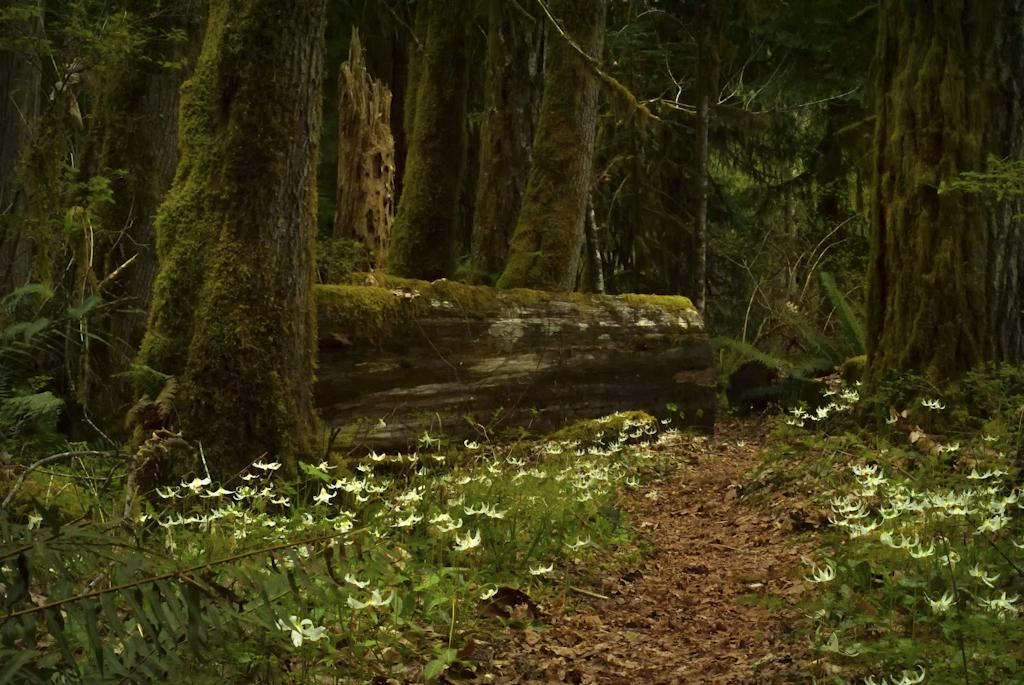What type of vegetation can be seen in the image? There are plants, flowers, and trees in the image. Can you describe the trees in the image? The trees in the image have tree trunks. How many pockets are visible on the goose in the image? There is no goose present in the image, so there are no pockets to count. 